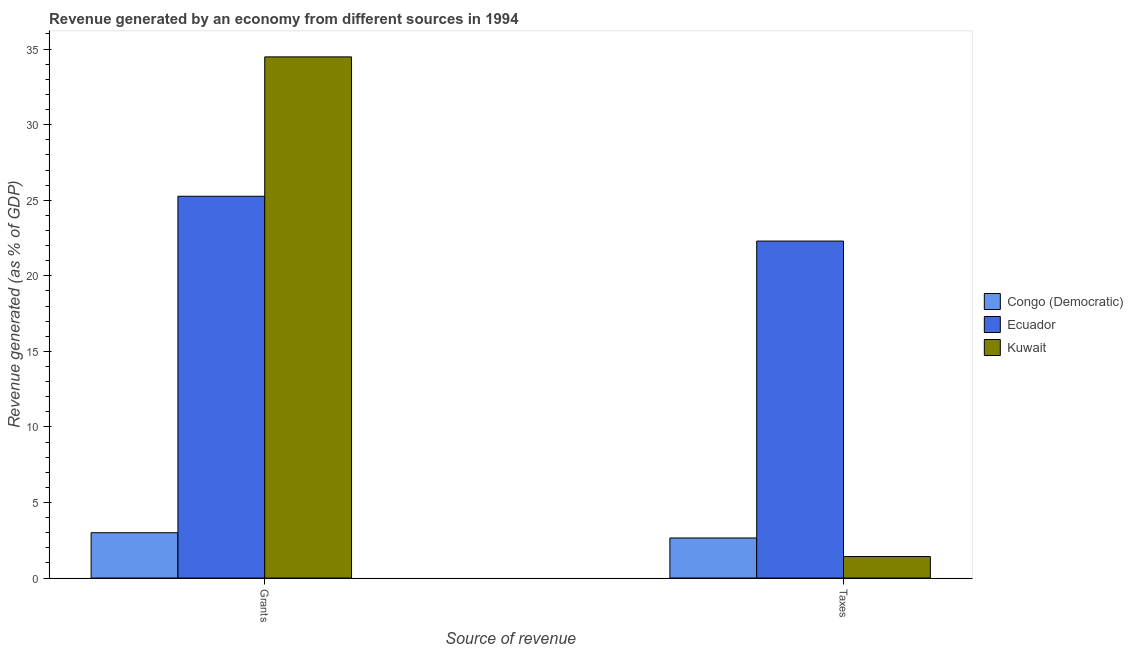How many groups of bars are there?
Offer a terse response. 2. Are the number of bars per tick equal to the number of legend labels?
Offer a terse response. Yes. How many bars are there on the 2nd tick from the left?
Ensure brevity in your answer.  3. How many bars are there on the 1st tick from the right?
Your response must be concise. 3. What is the label of the 2nd group of bars from the left?
Ensure brevity in your answer.  Taxes. What is the revenue generated by taxes in Ecuador?
Make the answer very short. 22.3. Across all countries, what is the maximum revenue generated by taxes?
Provide a succinct answer. 22.3. Across all countries, what is the minimum revenue generated by grants?
Offer a terse response. 3. In which country was the revenue generated by grants maximum?
Make the answer very short. Kuwait. In which country was the revenue generated by grants minimum?
Keep it short and to the point. Congo (Democratic). What is the total revenue generated by grants in the graph?
Offer a terse response. 62.75. What is the difference between the revenue generated by taxes in Congo (Democratic) and that in Ecuador?
Keep it short and to the point. -19.65. What is the difference between the revenue generated by taxes in Congo (Democratic) and the revenue generated by grants in Ecuador?
Your answer should be compact. -22.61. What is the average revenue generated by grants per country?
Offer a terse response. 20.92. What is the difference between the revenue generated by taxes and revenue generated by grants in Congo (Democratic)?
Offer a very short reply. -0.35. In how many countries, is the revenue generated by grants greater than 35 %?
Provide a short and direct response. 0. What is the ratio of the revenue generated by taxes in Ecuador to that in Kuwait?
Give a very brief answer. 15.67. Is the revenue generated by taxes in Ecuador less than that in Kuwait?
Give a very brief answer. No. In how many countries, is the revenue generated by taxes greater than the average revenue generated by taxes taken over all countries?
Provide a succinct answer. 1. What does the 2nd bar from the left in Grants represents?
Give a very brief answer. Ecuador. What does the 1st bar from the right in Taxes represents?
Offer a terse response. Kuwait. Are the values on the major ticks of Y-axis written in scientific E-notation?
Give a very brief answer. No. Where does the legend appear in the graph?
Provide a short and direct response. Center right. What is the title of the graph?
Your answer should be very brief. Revenue generated by an economy from different sources in 1994. Does "France" appear as one of the legend labels in the graph?
Your answer should be very brief. No. What is the label or title of the X-axis?
Your response must be concise. Source of revenue. What is the label or title of the Y-axis?
Your answer should be very brief. Revenue generated (as % of GDP). What is the Revenue generated (as % of GDP) of Congo (Democratic) in Grants?
Ensure brevity in your answer.  3. What is the Revenue generated (as % of GDP) of Ecuador in Grants?
Your answer should be very brief. 25.26. What is the Revenue generated (as % of GDP) of Kuwait in Grants?
Provide a short and direct response. 34.49. What is the Revenue generated (as % of GDP) of Congo (Democratic) in Taxes?
Your answer should be compact. 2.65. What is the Revenue generated (as % of GDP) of Ecuador in Taxes?
Give a very brief answer. 22.3. What is the Revenue generated (as % of GDP) of Kuwait in Taxes?
Your response must be concise. 1.42. Across all Source of revenue, what is the maximum Revenue generated (as % of GDP) of Congo (Democratic)?
Your answer should be compact. 3. Across all Source of revenue, what is the maximum Revenue generated (as % of GDP) in Ecuador?
Give a very brief answer. 25.26. Across all Source of revenue, what is the maximum Revenue generated (as % of GDP) in Kuwait?
Offer a terse response. 34.49. Across all Source of revenue, what is the minimum Revenue generated (as % of GDP) in Congo (Democratic)?
Your answer should be compact. 2.65. Across all Source of revenue, what is the minimum Revenue generated (as % of GDP) in Ecuador?
Make the answer very short. 22.3. Across all Source of revenue, what is the minimum Revenue generated (as % of GDP) in Kuwait?
Offer a very short reply. 1.42. What is the total Revenue generated (as % of GDP) of Congo (Democratic) in the graph?
Offer a very short reply. 5.65. What is the total Revenue generated (as % of GDP) in Ecuador in the graph?
Offer a very short reply. 47.56. What is the total Revenue generated (as % of GDP) of Kuwait in the graph?
Your answer should be compact. 35.91. What is the difference between the Revenue generated (as % of GDP) in Congo (Democratic) in Grants and that in Taxes?
Offer a terse response. 0.35. What is the difference between the Revenue generated (as % of GDP) in Ecuador in Grants and that in Taxes?
Ensure brevity in your answer.  2.97. What is the difference between the Revenue generated (as % of GDP) in Kuwait in Grants and that in Taxes?
Offer a terse response. 33.06. What is the difference between the Revenue generated (as % of GDP) of Congo (Democratic) in Grants and the Revenue generated (as % of GDP) of Ecuador in Taxes?
Your answer should be very brief. -19.3. What is the difference between the Revenue generated (as % of GDP) of Congo (Democratic) in Grants and the Revenue generated (as % of GDP) of Kuwait in Taxes?
Provide a short and direct response. 1.58. What is the difference between the Revenue generated (as % of GDP) in Ecuador in Grants and the Revenue generated (as % of GDP) in Kuwait in Taxes?
Make the answer very short. 23.84. What is the average Revenue generated (as % of GDP) of Congo (Democratic) per Source of revenue?
Give a very brief answer. 2.82. What is the average Revenue generated (as % of GDP) in Ecuador per Source of revenue?
Provide a succinct answer. 23.78. What is the average Revenue generated (as % of GDP) in Kuwait per Source of revenue?
Your response must be concise. 17.95. What is the difference between the Revenue generated (as % of GDP) of Congo (Democratic) and Revenue generated (as % of GDP) of Ecuador in Grants?
Your answer should be compact. -22.26. What is the difference between the Revenue generated (as % of GDP) in Congo (Democratic) and Revenue generated (as % of GDP) in Kuwait in Grants?
Your answer should be very brief. -31.49. What is the difference between the Revenue generated (as % of GDP) in Ecuador and Revenue generated (as % of GDP) in Kuwait in Grants?
Ensure brevity in your answer.  -9.22. What is the difference between the Revenue generated (as % of GDP) of Congo (Democratic) and Revenue generated (as % of GDP) of Ecuador in Taxes?
Offer a very short reply. -19.65. What is the difference between the Revenue generated (as % of GDP) in Congo (Democratic) and Revenue generated (as % of GDP) in Kuwait in Taxes?
Provide a succinct answer. 1.23. What is the difference between the Revenue generated (as % of GDP) in Ecuador and Revenue generated (as % of GDP) in Kuwait in Taxes?
Make the answer very short. 20.88. What is the ratio of the Revenue generated (as % of GDP) of Congo (Democratic) in Grants to that in Taxes?
Make the answer very short. 1.13. What is the ratio of the Revenue generated (as % of GDP) of Ecuador in Grants to that in Taxes?
Keep it short and to the point. 1.13. What is the ratio of the Revenue generated (as % of GDP) of Kuwait in Grants to that in Taxes?
Provide a short and direct response. 24.24. What is the difference between the highest and the second highest Revenue generated (as % of GDP) of Congo (Democratic)?
Offer a very short reply. 0.35. What is the difference between the highest and the second highest Revenue generated (as % of GDP) in Ecuador?
Provide a succinct answer. 2.97. What is the difference between the highest and the second highest Revenue generated (as % of GDP) in Kuwait?
Offer a very short reply. 33.06. What is the difference between the highest and the lowest Revenue generated (as % of GDP) in Congo (Democratic)?
Give a very brief answer. 0.35. What is the difference between the highest and the lowest Revenue generated (as % of GDP) in Ecuador?
Provide a short and direct response. 2.97. What is the difference between the highest and the lowest Revenue generated (as % of GDP) in Kuwait?
Provide a succinct answer. 33.06. 